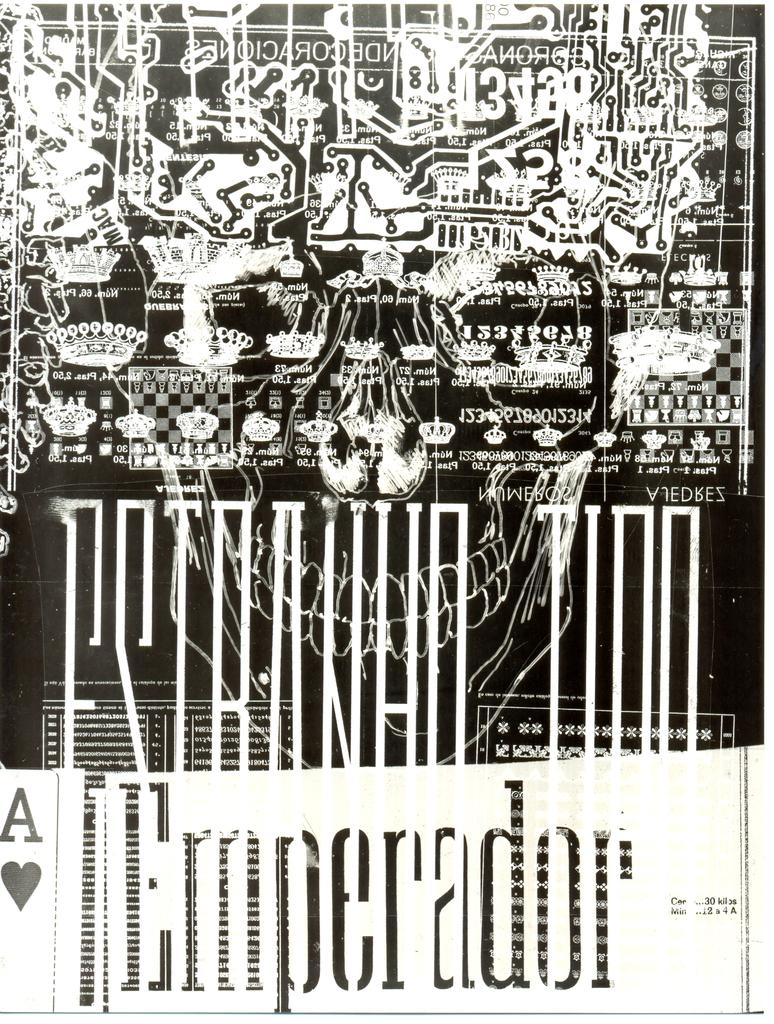Provide a one-sentence caption for the provided image. The picture has an ace of hearts in the bottom corner. 